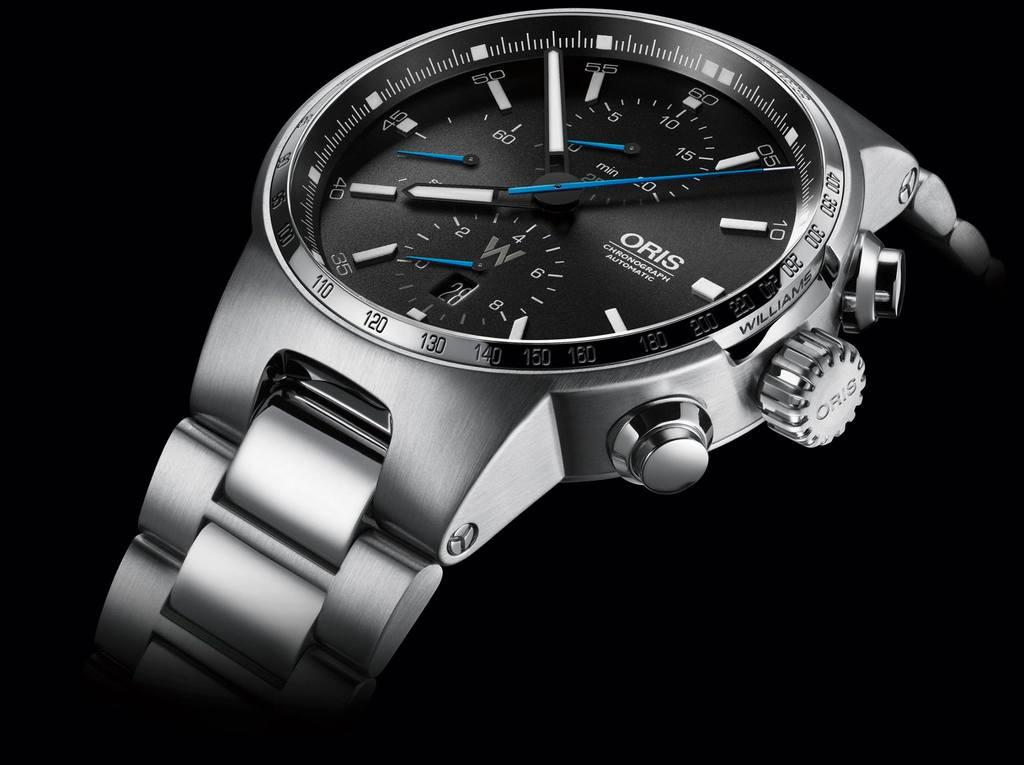<image>
Give a short and clear explanation of the subsequent image. silver oris chronograph automatic watch against a black background 